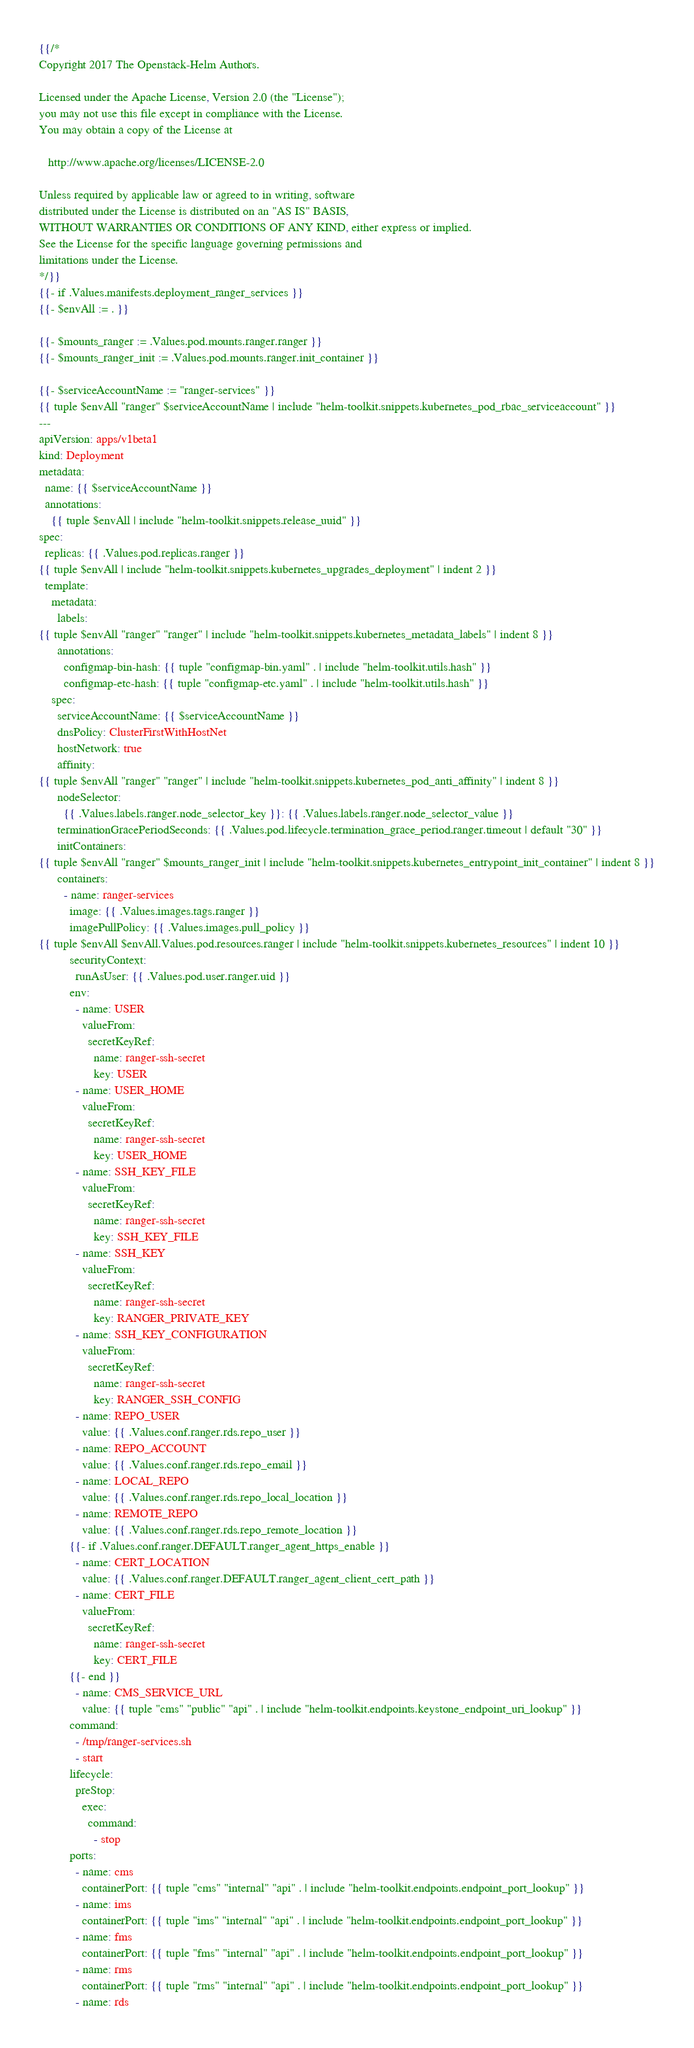<code> <loc_0><loc_0><loc_500><loc_500><_YAML_>{{/*
Copyright 2017 The Openstack-Helm Authors.

Licensed under the Apache License, Version 2.0 (the "License");
you may not use this file except in compliance with the License.
You may obtain a copy of the License at

   http://www.apache.org/licenses/LICENSE-2.0

Unless required by applicable law or agreed to in writing, software
distributed under the License is distributed on an "AS IS" BASIS,
WITHOUT WARRANTIES OR CONDITIONS OF ANY KIND, either express or implied.
See the License for the specific language governing permissions and
limitations under the License.
*/}}
{{- if .Values.manifests.deployment_ranger_services }}
{{- $envAll := . }}

{{- $mounts_ranger := .Values.pod.mounts.ranger.ranger }}
{{- $mounts_ranger_init := .Values.pod.mounts.ranger.init_container }}

{{- $serviceAccountName := "ranger-services" }}
{{ tuple $envAll "ranger" $serviceAccountName | include "helm-toolkit.snippets.kubernetes_pod_rbac_serviceaccount" }}
---
apiVersion: apps/v1beta1
kind: Deployment
metadata:
  name: {{ $serviceAccountName }}
  annotations:
    {{ tuple $envAll | include "helm-toolkit.snippets.release_uuid" }}
spec:
  replicas: {{ .Values.pod.replicas.ranger }}
{{ tuple $envAll | include "helm-toolkit.snippets.kubernetes_upgrades_deployment" | indent 2 }}
  template:
    metadata:
      labels:
{{ tuple $envAll "ranger" "ranger" | include "helm-toolkit.snippets.kubernetes_metadata_labels" | indent 8 }}
      annotations:
        configmap-bin-hash: {{ tuple "configmap-bin.yaml" . | include "helm-toolkit.utils.hash" }}
        configmap-etc-hash: {{ tuple "configmap-etc.yaml" . | include "helm-toolkit.utils.hash" }}
    spec:
      serviceAccountName: {{ $serviceAccountName }}
      dnsPolicy: ClusterFirstWithHostNet
      hostNetwork: true
      affinity:
{{ tuple $envAll "ranger" "ranger" | include "helm-toolkit.snippets.kubernetes_pod_anti_affinity" | indent 8 }}
      nodeSelector:
        {{ .Values.labels.ranger.node_selector_key }}: {{ .Values.labels.ranger.node_selector_value }}
      terminationGracePeriodSeconds: {{ .Values.pod.lifecycle.termination_grace_period.ranger.timeout | default "30" }}
      initContainers:
{{ tuple $envAll "ranger" $mounts_ranger_init | include "helm-toolkit.snippets.kubernetes_entrypoint_init_container" | indent 8 }}
      containers:
        - name: ranger-services
          image: {{ .Values.images.tags.ranger }}
          imagePullPolicy: {{ .Values.images.pull_policy }}
{{ tuple $envAll $envAll.Values.pod.resources.ranger | include "helm-toolkit.snippets.kubernetes_resources" | indent 10 }}
          securityContext:
            runAsUser: {{ .Values.pod.user.ranger.uid }}
          env:
            - name: USER
              valueFrom:
                secretKeyRef:
                  name: ranger-ssh-secret
                  key: USER
            - name: USER_HOME
              valueFrom:
                secretKeyRef:
                  name: ranger-ssh-secret
                  key: USER_HOME
            - name: SSH_KEY_FILE
              valueFrom:
                secretKeyRef:
                  name: ranger-ssh-secret
                  key: SSH_KEY_FILE
            - name: SSH_KEY
              valueFrom:
                secretKeyRef:
                  name: ranger-ssh-secret
                  key: RANGER_PRIVATE_KEY
            - name: SSH_KEY_CONFIGURATION
              valueFrom:
                secretKeyRef:
                  name: ranger-ssh-secret
                  key: RANGER_SSH_CONFIG
            - name: REPO_USER
              value: {{ .Values.conf.ranger.rds.repo_user }}
            - name: REPO_ACCOUNT
              value: {{ .Values.conf.ranger.rds.repo_email }}
            - name: LOCAL_REPO
              value: {{ .Values.conf.ranger.rds.repo_local_location }}
            - name: REMOTE_REPO
              value: {{ .Values.conf.ranger.rds.repo_remote_location }}
          {{- if .Values.conf.ranger.DEFAULT.ranger_agent_https_enable }}
            - name: CERT_LOCATION
              value: {{ .Values.conf.ranger.DEFAULT.ranger_agent_client_cert_path }}
            - name: CERT_FILE
              valueFrom:
                secretKeyRef:
                  name: ranger-ssh-secret
                  key: CERT_FILE
          {{- end }}
            - name: CMS_SERVICE_URL
              value: {{ tuple "cms" "public" "api" . | include "helm-toolkit.endpoints.keystone_endpoint_uri_lookup" }}
          command:
            - /tmp/ranger-services.sh
            - start
          lifecycle:
            preStop:
              exec:
                command:
                  - stop
          ports:
            - name: cms
              containerPort: {{ tuple "cms" "internal" "api" . | include "helm-toolkit.endpoints.endpoint_port_lookup" }}
            - name: ims
              containerPort: {{ tuple "ims" "internal" "api" . | include "helm-toolkit.endpoints.endpoint_port_lookup" }}
            - name: fms
              containerPort: {{ tuple "fms" "internal" "api" . | include "helm-toolkit.endpoints.endpoint_port_lookup" }}
            - name: rms
              containerPort: {{ tuple "rms" "internal" "api" . | include "helm-toolkit.endpoints.endpoint_port_lookup" }}
            - name: rds</code> 